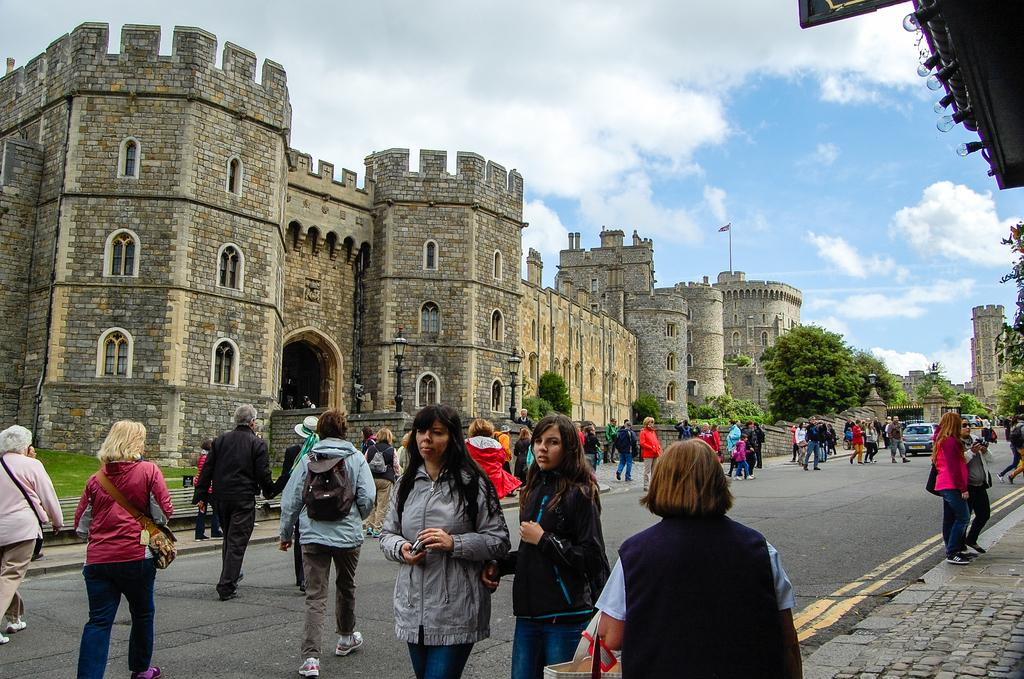Who or what can be seen at the bottom side of the image? There are people at the bottom side of the image. What structure is located in the center of the image? There is a building in the center of the image. What types of vehicles are on the right side of the image? There are cars on the right side of the image. What type of vegetation is on the right side of the image? There are trees on the right side of the image. What arithmetic problem is being solved by the people in the image? There is no indication in the image that the people are solving an arithmetic problem. What type of beef is being served at the building in the image? There is no beef present in the image, and the image does not depict any food being served. 